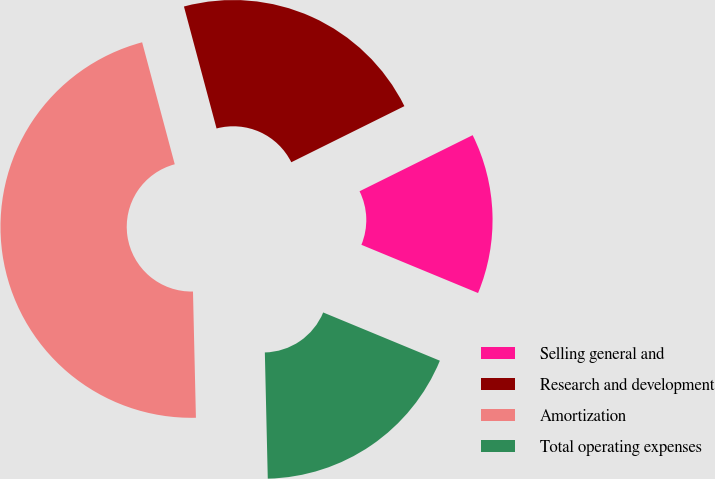Convert chart. <chart><loc_0><loc_0><loc_500><loc_500><pie_chart><fcel>Selling general and<fcel>Research and development<fcel>Amortization<fcel>Total operating expenses<nl><fcel>13.57%<fcel>21.83%<fcel>46.21%<fcel>18.39%<nl></chart> 